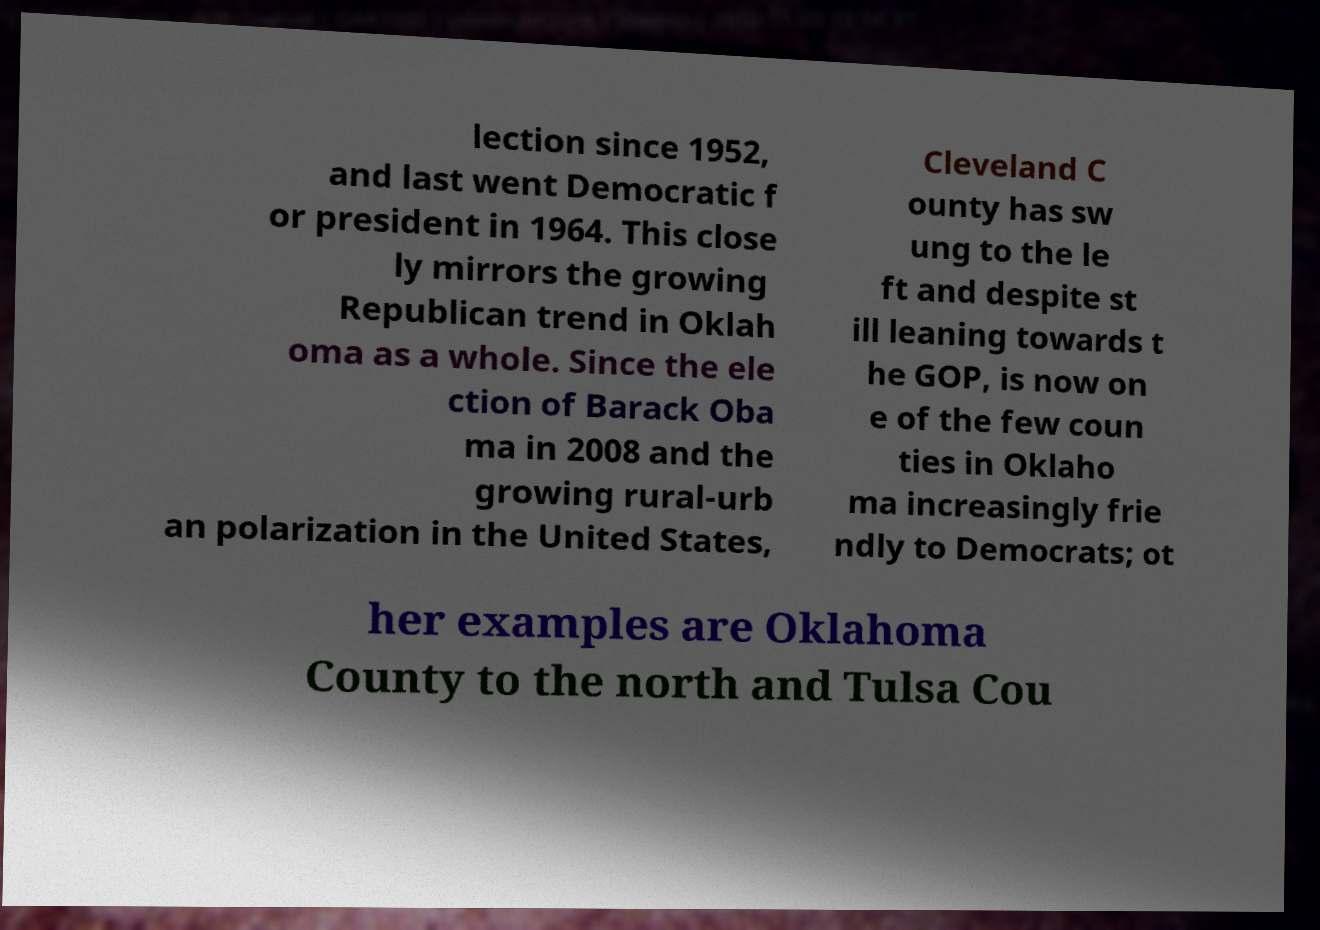What messages or text are displayed in this image? I need them in a readable, typed format. lection since 1952, and last went Democratic f or president in 1964. This close ly mirrors the growing Republican trend in Oklah oma as a whole. Since the ele ction of Barack Oba ma in 2008 and the growing rural-urb an polarization in the United States, Cleveland C ounty has sw ung to the le ft and despite st ill leaning towards t he GOP, is now on e of the few coun ties in Oklaho ma increasingly frie ndly to Democrats; ot her examples are Oklahoma County to the north and Tulsa Cou 